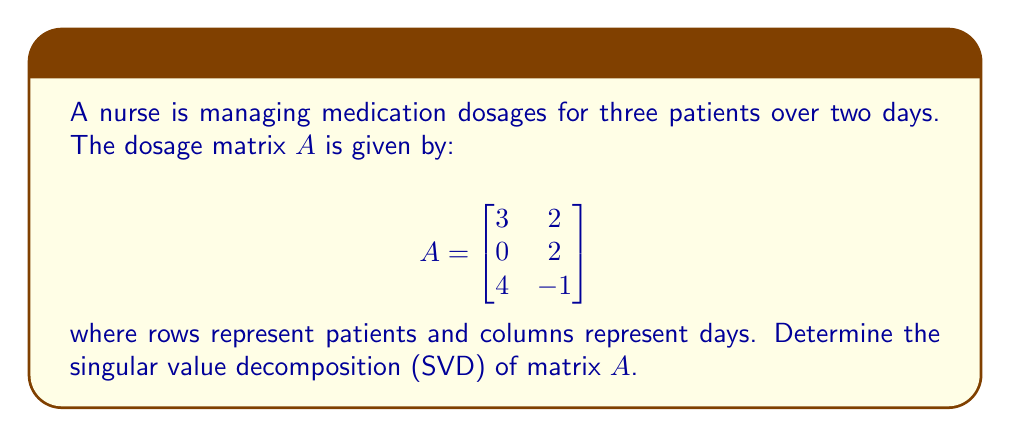Can you answer this question? To find the singular value decomposition of matrix $A$, we need to determine matrices $U$, $\Sigma$, and $V^T$ such that $A = U\Sigma V^T$.

Step 1: Calculate $A^TA$ and $AA^T$

$A^TA = \begin{bmatrix}
3 & 0 & 4 \\
2 & 2 & -1
\end{bmatrix} \begin{bmatrix}
3 & 2 \\
0 & 2 \\
4 & -1
\end{bmatrix} = \begin{bmatrix}
25 & 2 \\
2 & 9
\end{bmatrix}$

$AA^T = \begin{bmatrix}
3 & 2 \\
0 & 2 \\
4 & -1
\end{bmatrix} \begin{bmatrix}
3 & 0 & 4 \\
2 & 2 & -1
\end{bmatrix} = \begin{bmatrix}
13 & 6 & 10 \\
6 & 4 & -2 \\
10 & -2 & 17
\end{bmatrix}$

Step 2: Find eigenvalues of $A^TA$

$\det(A^TA - \lambda I) = \begin{vmatrix}
25-\lambda & 2 \\
2 & 9-\lambda
\end{vmatrix} = (25-\lambda)(9-\lambda) - 4 = \lambda^2 - 34\lambda + 221 = 0$

Solving this equation, we get $\lambda_1 = 26$ and $\lambda_2 = 8$.

Step 3: Calculate singular values

The singular values are the square roots of the eigenvalues of $A^TA$:
$\sigma_1 = \sqrt{26} \approx 5.10$ and $\sigma_2 = \sqrt{8} \approx 2.83$

Step 4: Find right singular vectors (columns of $V$)

For $\lambda_1 = 26$:
$(A^TA - 26I)v_1 = 0$
$\begin{bmatrix}
-1 & 2 \\
2 & -17
\end{bmatrix} \begin{bmatrix}
x \\
y
\end{bmatrix} = \begin{bmatrix}
0 \\
0
\end{bmatrix}$

Solving this, we get $v_1 = \frac{1}{\sqrt{5}} \begin{bmatrix}
2 \\
1
\end{bmatrix}$

For $\lambda_2 = 8$:
$(A^TA - 8I)v_2 = 0$
$\begin{bmatrix}
17 & 2 \\
2 & 1
\end{bmatrix} \begin{bmatrix}
x \\
y
\end{bmatrix} = \begin{bmatrix}
0 \\
0
\end{bmatrix}$

Solving this, we get $v_2 = \frac{1}{\sqrt{5}} \begin{bmatrix}
-1 \\
2
\end{bmatrix}$

Step 5: Find left singular vectors (columns of $U$)

$u_1 = \frac{1}{\sigma_1}Av_1 = \frac{1}{5.10} \begin{bmatrix}
3 & 2 \\
0 & 2 \\
4 & -1
\end{bmatrix} \frac{1}{\sqrt{5}} \begin{bmatrix}
2 \\
1
\end{bmatrix} \approx \begin{bmatrix}
0.59 \\
0.16 \\
0.79
\end{bmatrix}$

$u_2 = \frac{1}{\sigma_2}Av_2 = \frac{1}{2.83} \begin{bmatrix}
3 & 2 \\
0 & 2 \\
4 & -1
\end{bmatrix} \frac{1}{\sqrt{5}} \begin{bmatrix}
-1 \\
2
\end{bmatrix} \approx \begin{bmatrix}
0.04 \\
0.71 \\
-0.70
\end{bmatrix}$

Step 6: Construct matrices $U$, $\Sigma$, and $V^T$

$U = \begin{bmatrix}
0.59 & 0.04 \\
0.16 & 0.71 \\
0.79 & -0.70
\end{bmatrix}$

$\Sigma = \begin{bmatrix}
5.10 & 0 \\
0 & 2.83 \\
0 & 0
\end{bmatrix}$

$V^T = \begin{bmatrix}
0.89 & 0.45 \\
-0.45 & 0.89
\end{bmatrix}$
Answer: $A = U\Sigma V^T$, where $U = \begin{bmatrix}
0.59 & 0.04 \\
0.16 & 0.71 \\
0.79 & -0.70
\end{bmatrix}$, $\Sigma = \begin{bmatrix}
5.10 & 0 \\
0 & 2.83 \\
0 & 0
\end{bmatrix}$, $V^T = \begin{bmatrix}
0.89 & 0.45 \\
-0.45 & 0.89
\end{bmatrix}$ 